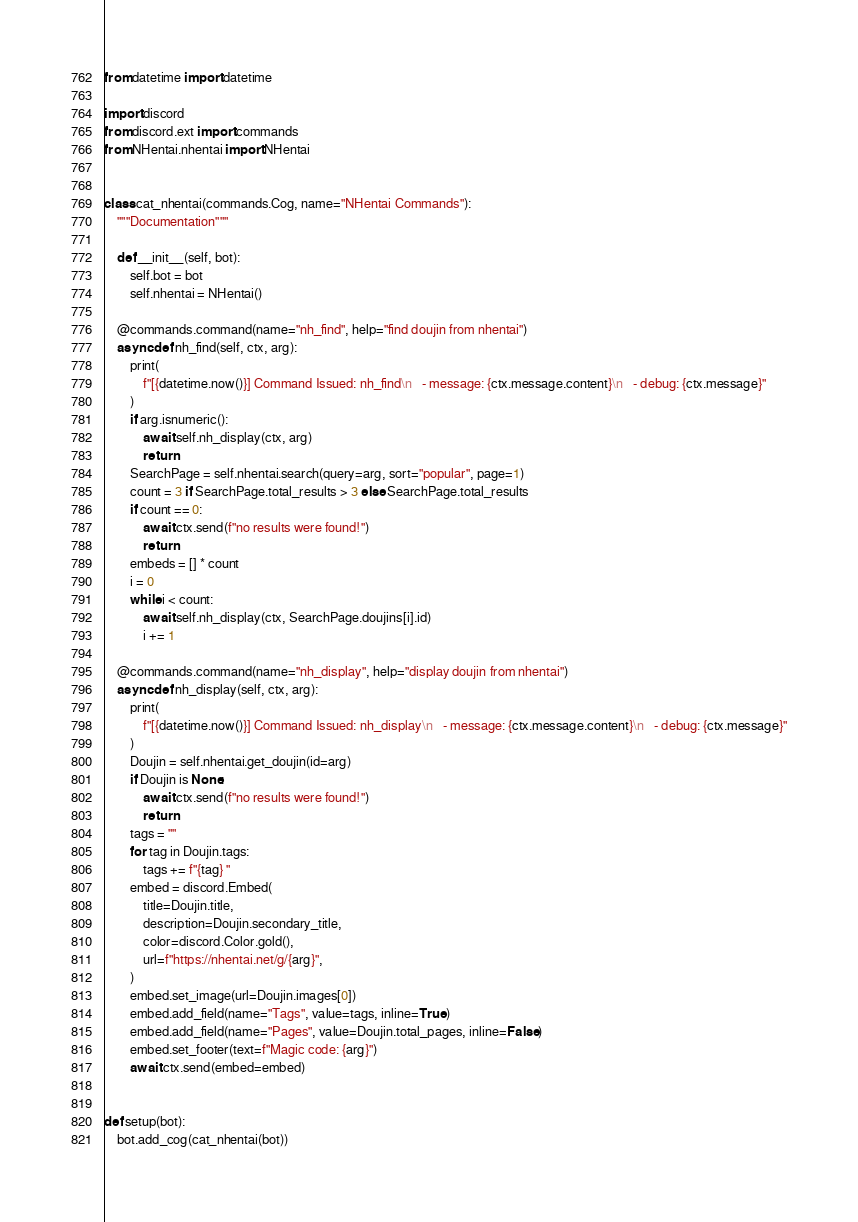Convert code to text. <code><loc_0><loc_0><loc_500><loc_500><_Python_>from datetime import datetime

import discord
from discord.ext import commands
from NHentai.nhentai import NHentai


class cat_nhentai(commands.Cog, name="NHentai Commands"):
    """Documentation"""

    def __init__(self, bot):
        self.bot = bot
        self.nhentai = NHentai()

    @commands.command(name="nh_find", help="find doujin from nhentai")
    async def nh_find(self, ctx, arg):
        print(
            f"[{datetime.now()}] Command Issued: nh_find\n   - message: {ctx.message.content}\n   - debug: {ctx.message}"
        )
        if arg.isnumeric():
            await self.nh_display(ctx, arg)
            return
        SearchPage = self.nhentai.search(query=arg, sort="popular", page=1)
        count = 3 if SearchPage.total_results > 3 else SearchPage.total_results
        if count == 0:
            await ctx.send(f"no results were found!")
            return
        embeds = [] * count
        i = 0
        while i < count:
            await self.nh_display(ctx, SearchPage.doujins[i].id)
            i += 1

    @commands.command(name="nh_display", help="display doujin from nhentai")
    async def nh_display(self, ctx, arg):
        print(
            f"[{datetime.now()}] Command Issued: nh_display\n   - message: {ctx.message.content}\n   - debug: {ctx.message}"
        )
        Doujin = self.nhentai.get_doujin(id=arg)
        if Doujin is None:
            await ctx.send(f"no results were found!")
            return
        tags = ""
        for tag in Doujin.tags:
            tags += f"{tag} "
        embed = discord.Embed(
            title=Doujin.title,
            description=Doujin.secondary_title,
            color=discord.Color.gold(),
            url=f"https://nhentai.net/g/{arg}",
        )
        embed.set_image(url=Doujin.images[0])
        embed.add_field(name="Tags", value=tags, inline=True)
        embed.add_field(name="Pages", value=Doujin.total_pages, inline=False)
        embed.set_footer(text=f"Magic code: {arg}")
        await ctx.send(embed=embed)


def setup(bot):
    bot.add_cog(cat_nhentai(bot))
</code> 